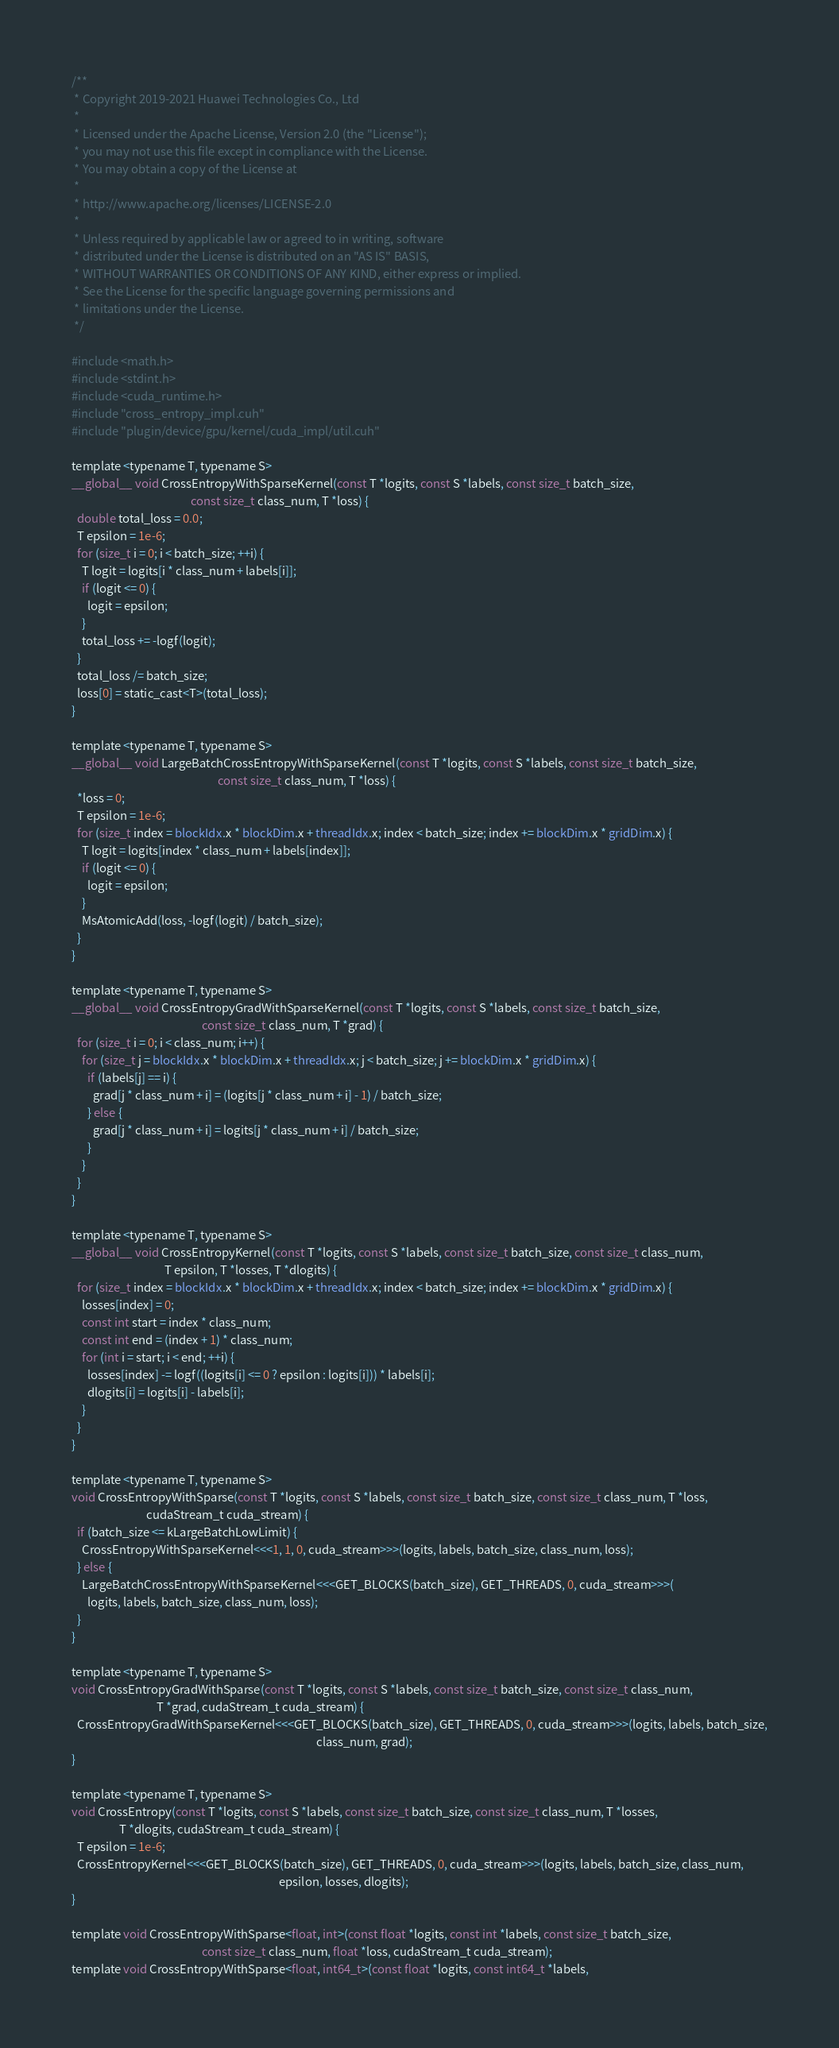Convert code to text. <code><loc_0><loc_0><loc_500><loc_500><_Cuda_>/**
 * Copyright 2019-2021 Huawei Technologies Co., Ltd
 *
 * Licensed under the Apache License, Version 2.0 (the "License");
 * you may not use this file except in compliance with the License.
 * You may obtain a copy of the License at
 *
 * http://www.apache.org/licenses/LICENSE-2.0
 *
 * Unless required by applicable law or agreed to in writing, software
 * distributed under the License is distributed on an "AS IS" BASIS,
 * WITHOUT WARRANTIES OR CONDITIONS OF ANY KIND, either express or implied.
 * See the License for the specific language governing permissions and
 * limitations under the License.
 */

#include <math.h>
#include <stdint.h>
#include <cuda_runtime.h>
#include "cross_entropy_impl.cuh"
#include "plugin/device/gpu/kernel/cuda_impl/util.cuh"

template <typename T, typename S>
__global__ void CrossEntropyWithSparseKernel(const T *logits, const S *labels, const size_t batch_size,
                                             const size_t class_num, T *loss) {
  double total_loss = 0.0;
  T epsilon = 1e-6;
  for (size_t i = 0; i < batch_size; ++i) {
    T logit = logits[i * class_num + labels[i]];
    if (logit <= 0) {
      logit = epsilon;
    }
    total_loss += -logf(logit);
  }
  total_loss /= batch_size;
  loss[0] = static_cast<T>(total_loss);
}

template <typename T, typename S>
__global__ void LargeBatchCrossEntropyWithSparseKernel(const T *logits, const S *labels, const size_t batch_size,
                                                       const size_t class_num, T *loss) {
  *loss = 0;
  T epsilon = 1e-6;
  for (size_t index = blockIdx.x * blockDim.x + threadIdx.x; index < batch_size; index += blockDim.x * gridDim.x) {
    T logit = logits[index * class_num + labels[index]];
    if (logit <= 0) {
      logit = epsilon;
    }
    MsAtomicAdd(loss, -logf(logit) / batch_size);
  }
}

template <typename T, typename S>
__global__ void CrossEntropyGradWithSparseKernel(const T *logits, const S *labels, const size_t batch_size,
                                                 const size_t class_num, T *grad) {
  for (size_t i = 0; i < class_num; i++) {
    for (size_t j = blockIdx.x * blockDim.x + threadIdx.x; j < batch_size; j += blockDim.x * gridDim.x) {
      if (labels[j] == i) {
        grad[j * class_num + i] = (logits[j * class_num + i] - 1) / batch_size;
      } else {
        grad[j * class_num + i] = logits[j * class_num + i] / batch_size;
      }
    }
  }
}

template <typename T, typename S>
__global__ void CrossEntropyKernel(const T *logits, const S *labels, const size_t batch_size, const size_t class_num,
                                   T epsilon, T *losses, T *dlogits) {
  for (size_t index = blockIdx.x * blockDim.x + threadIdx.x; index < batch_size; index += blockDim.x * gridDim.x) {
    losses[index] = 0;
    const int start = index * class_num;
    const int end = (index + 1) * class_num;
    for (int i = start; i < end; ++i) {
      losses[index] -= logf((logits[i] <= 0 ? epsilon : logits[i])) * labels[i];
      dlogits[i] = logits[i] - labels[i];
    }
  }
}

template <typename T, typename S>
void CrossEntropyWithSparse(const T *logits, const S *labels, const size_t batch_size, const size_t class_num, T *loss,
                            cudaStream_t cuda_stream) {
  if (batch_size <= kLargeBatchLowLimit) {
    CrossEntropyWithSparseKernel<<<1, 1, 0, cuda_stream>>>(logits, labels, batch_size, class_num, loss);
  } else {
    LargeBatchCrossEntropyWithSparseKernel<<<GET_BLOCKS(batch_size), GET_THREADS, 0, cuda_stream>>>(
      logits, labels, batch_size, class_num, loss);
  }
}

template <typename T, typename S>
void CrossEntropyGradWithSparse(const T *logits, const S *labels, const size_t batch_size, const size_t class_num,
                                T *grad, cudaStream_t cuda_stream) {
  CrossEntropyGradWithSparseKernel<<<GET_BLOCKS(batch_size), GET_THREADS, 0, cuda_stream>>>(logits, labels, batch_size,
                                                                                            class_num, grad);
}

template <typename T, typename S>
void CrossEntropy(const T *logits, const S *labels, const size_t batch_size, const size_t class_num, T *losses,
                  T *dlogits, cudaStream_t cuda_stream) {
  T epsilon = 1e-6;
  CrossEntropyKernel<<<GET_BLOCKS(batch_size), GET_THREADS, 0, cuda_stream>>>(logits, labels, batch_size, class_num,
                                                                              epsilon, losses, dlogits);
}

template void CrossEntropyWithSparse<float, int>(const float *logits, const int *labels, const size_t batch_size,
                                                 const size_t class_num, float *loss, cudaStream_t cuda_stream);
template void CrossEntropyWithSparse<float, int64_t>(const float *logits, const int64_t *labels,</code> 